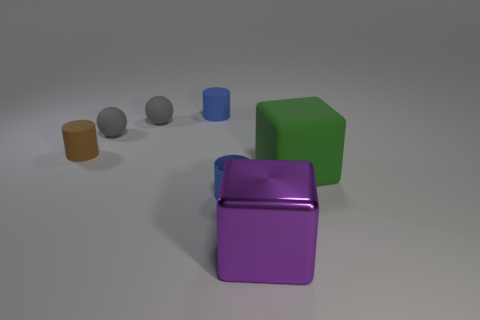How many other things are there of the same material as the small brown object?
Your answer should be very brief. 4. How many matte things are gray things or purple things?
Give a very brief answer. 2. Does the matte thing on the right side of the small blue metal cylinder have the same shape as the big purple object?
Offer a very short reply. Yes. Is the number of matte things that are right of the green matte cube greater than the number of big metal blocks?
Your answer should be very brief. No. What number of rubber objects are in front of the tiny blue rubber cylinder and behind the tiny brown cylinder?
Ensure brevity in your answer.  2. What color is the small cylinder that is left of the small blue object to the left of the blue shiny object?
Provide a succinct answer. Brown. What number of small metallic cylinders have the same color as the large metallic thing?
Provide a succinct answer. 0. There is a matte cube; is it the same color as the shiny thing behind the purple cube?
Provide a succinct answer. No. Is the number of blue metallic things less than the number of green rubber spheres?
Ensure brevity in your answer.  No. Are there more gray objects in front of the large purple thing than purple shiny things that are left of the tiny blue matte object?
Provide a short and direct response. No. 